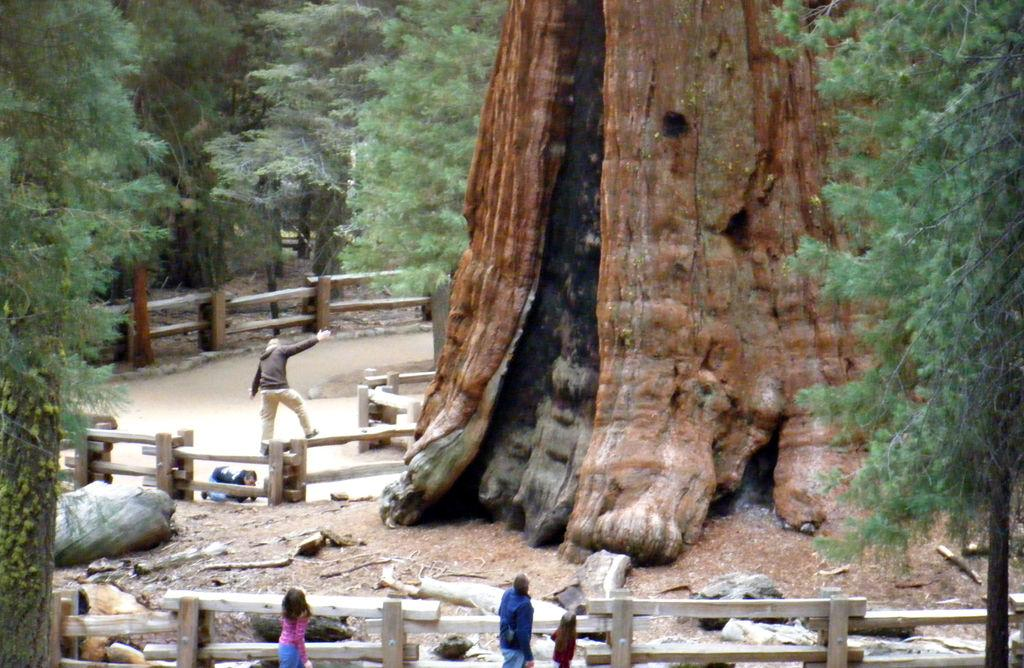What type of vegetation can be seen in the image? There are trees in the image. Can you describe the people in the image? There are people standing in the center of the image. What color is the crayon being used by the people in the image? There is no crayon present in the image. What type of neck accessory is being worn by the people in the image? There is no information about neck accessories in the image. 